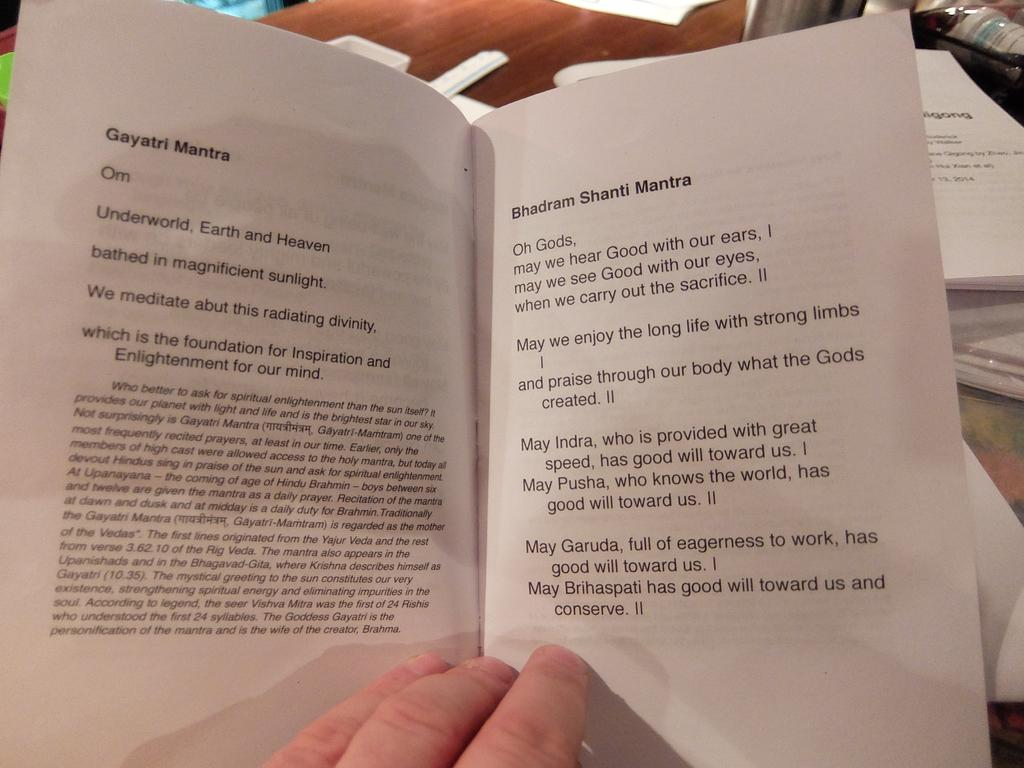<image>
Write a terse but informative summary of the picture. A man holds a book open dispaying different mantras, like the Gayatri Mantra. 